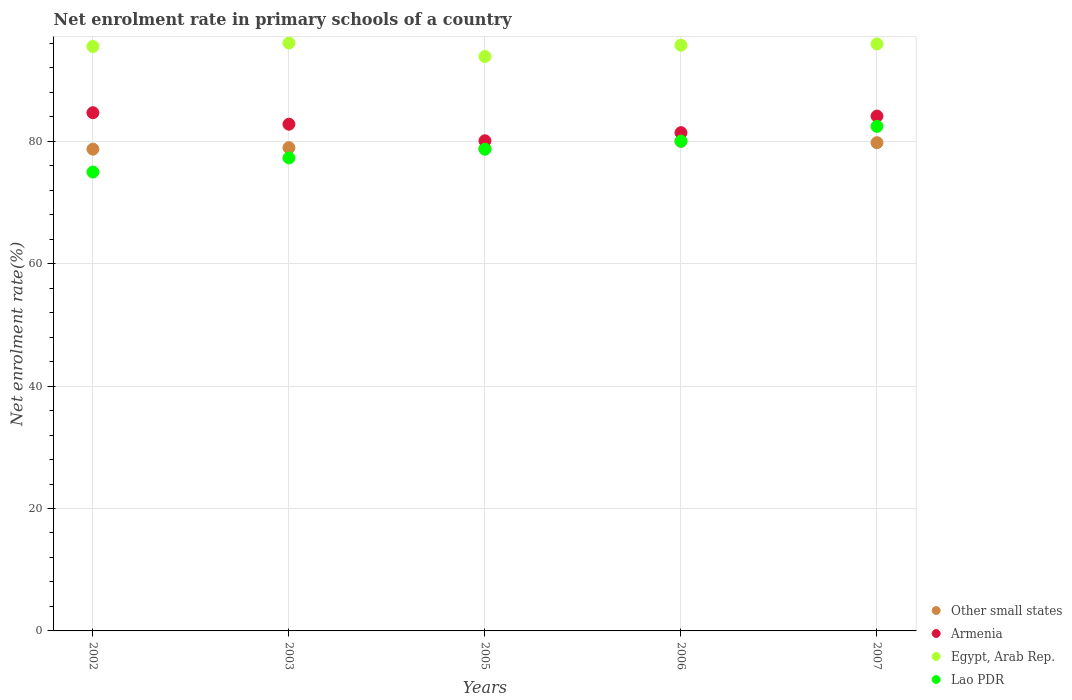Is the number of dotlines equal to the number of legend labels?
Your response must be concise. Yes. What is the net enrolment rate in primary schools in Armenia in 2005?
Ensure brevity in your answer.  80.09. Across all years, what is the maximum net enrolment rate in primary schools in Egypt, Arab Rep.?
Ensure brevity in your answer.  96.06. Across all years, what is the minimum net enrolment rate in primary schools in Egypt, Arab Rep.?
Your answer should be very brief. 93.85. What is the total net enrolment rate in primary schools in Lao PDR in the graph?
Your response must be concise. 393.45. What is the difference between the net enrolment rate in primary schools in Lao PDR in 2002 and that in 2003?
Keep it short and to the point. -2.31. What is the difference between the net enrolment rate in primary schools in Armenia in 2003 and the net enrolment rate in primary schools in Other small states in 2005?
Your answer should be very brief. 3.98. What is the average net enrolment rate in primary schools in Lao PDR per year?
Ensure brevity in your answer.  78.69. In the year 2003, what is the difference between the net enrolment rate in primary schools in Lao PDR and net enrolment rate in primary schools in Armenia?
Offer a terse response. -5.51. What is the ratio of the net enrolment rate in primary schools in Lao PDR in 2002 to that in 2007?
Your answer should be compact. 0.91. Is the difference between the net enrolment rate in primary schools in Lao PDR in 2003 and 2007 greater than the difference between the net enrolment rate in primary schools in Armenia in 2003 and 2007?
Provide a succinct answer. No. What is the difference between the highest and the second highest net enrolment rate in primary schools in Armenia?
Ensure brevity in your answer.  0.55. What is the difference between the highest and the lowest net enrolment rate in primary schools in Armenia?
Offer a terse response. 4.58. In how many years, is the net enrolment rate in primary schools in Lao PDR greater than the average net enrolment rate in primary schools in Lao PDR taken over all years?
Your response must be concise. 3. Is it the case that in every year, the sum of the net enrolment rate in primary schools in Other small states and net enrolment rate in primary schools in Lao PDR  is greater than the sum of net enrolment rate in primary schools in Armenia and net enrolment rate in primary schools in Egypt, Arab Rep.?
Give a very brief answer. No. Is the net enrolment rate in primary schools in Other small states strictly greater than the net enrolment rate in primary schools in Egypt, Arab Rep. over the years?
Your answer should be very brief. No. Is the net enrolment rate in primary schools in Armenia strictly less than the net enrolment rate in primary schools in Lao PDR over the years?
Offer a terse response. No. What is the difference between two consecutive major ticks on the Y-axis?
Give a very brief answer. 20. Are the values on the major ticks of Y-axis written in scientific E-notation?
Your response must be concise. No. Does the graph contain grids?
Keep it short and to the point. Yes. Where does the legend appear in the graph?
Give a very brief answer. Bottom right. How many legend labels are there?
Ensure brevity in your answer.  4. How are the legend labels stacked?
Make the answer very short. Vertical. What is the title of the graph?
Offer a very short reply. Net enrolment rate in primary schools of a country. What is the label or title of the Y-axis?
Give a very brief answer. Net enrolment rate(%). What is the Net enrolment rate(%) of Other small states in 2002?
Give a very brief answer. 78.72. What is the Net enrolment rate(%) in Armenia in 2002?
Your response must be concise. 84.67. What is the Net enrolment rate(%) in Egypt, Arab Rep. in 2002?
Ensure brevity in your answer.  95.49. What is the Net enrolment rate(%) of Lao PDR in 2002?
Keep it short and to the point. 74.98. What is the Net enrolment rate(%) of Other small states in 2003?
Provide a succinct answer. 78.96. What is the Net enrolment rate(%) of Armenia in 2003?
Your answer should be very brief. 82.79. What is the Net enrolment rate(%) of Egypt, Arab Rep. in 2003?
Ensure brevity in your answer.  96.06. What is the Net enrolment rate(%) in Lao PDR in 2003?
Your response must be concise. 77.29. What is the Net enrolment rate(%) of Other small states in 2005?
Provide a short and direct response. 78.81. What is the Net enrolment rate(%) of Armenia in 2005?
Give a very brief answer. 80.09. What is the Net enrolment rate(%) in Egypt, Arab Rep. in 2005?
Make the answer very short. 93.85. What is the Net enrolment rate(%) in Lao PDR in 2005?
Keep it short and to the point. 78.71. What is the Net enrolment rate(%) in Other small states in 2006?
Your answer should be very brief. 79.99. What is the Net enrolment rate(%) in Armenia in 2006?
Your response must be concise. 81.41. What is the Net enrolment rate(%) of Egypt, Arab Rep. in 2006?
Your answer should be compact. 95.7. What is the Net enrolment rate(%) in Lao PDR in 2006?
Your answer should be compact. 80.04. What is the Net enrolment rate(%) of Other small states in 2007?
Your response must be concise. 79.77. What is the Net enrolment rate(%) of Armenia in 2007?
Ensure brevity in your answer.  84.12. What is the Net enrolment rate(%) of Egypt, Arab Rep. in 2007?
Offer a very short reply. 95.9. What is the Net enrolment rate(%) of Lao PDR in 2007?
Ensure brevity in your answer.  82.44. Across all years, what is the maximum Net enrolment rate(%) of Other small states?
Your answer should be compact. 79.99. Across all years, what is the maximum Net enrolment rate(%) in Armenia?
Ensure brevity in your answer.  84.67. Across all years, what is the maximum Net enrolment rate(%) in Egypt, Arab Rep.?
Offer a very short reply. 96.06. Across all years, what is the maximum Net enrolment rate(%) in Lao PDR?
Your answer should be compact. 82.44. Across all years, what is the minimum Net enrolment rate(%) in Other small states?
Your response must be concise. 78.72. Across all years, what is the minimum Net enrolment rate(%) of Armenia?
Provide a short and direct response. 80.09. Across all years, what is the minimum Net enrolment rate(%) of Egypt, Arab Rep.?
Offer a terse response. 93.85. Across all years, what is the minimum Net enrolment rate(%) of Lao PDR?
Provide a succinct answer. 74.98. What is the total Net enrolment rate(%) of Other small states in the graph?
Offer a terse response. 396.26. What is the total Net enrolment rate(%) of Armenia in the graph?
Your answer should be very brief. 413.08. What is the total Net enrolment rate(%) of Egypt, Arab Rep. in the graph?
Make the answer very short. 477. What is the total Net enrolment rate(%) in Lao PDR in the graph?
Provide a succinct answer. 393.45. What is the difference between the Net enrolment rate(%) in Other small states in 2002 and that in 2003?
Ensure brevity in your answer.  -0.24. What is the difference between the Net enrolment rate(%) in Armenia in 2002 and that in 2003?
Offer a terse response. 1.88. What is the difference between the Net enrolment rate(%) in Egypt, Arab Rep. in 2002 and that in 2003?
Make the answer very short. -0.56. What is the difference between the Net enrolment rate(%) of Lao PDR in 2002 and that in 2003?
Your answer should be very brief. -2.31. What is the difference between the Net enrolment rate(%) in Other small states in 2002 and that in 2005?
Provide a succinct answer. -0.1. What is the difference between the Net enrolment rate(%) in Armenia in 2002 and that in 2005?
Provide a succinct answer. 4.58. What is the difference between the Net enrolment rate(%) in Egypt, Arab Rep. in 2002 and that in 2005?
Ensure brevity in your answer.  1.64. What is the difference between the Net enrolment rate(%) of Lao PDR in 2002 and that in 2005?
Keep it short and to the point. -3.73. What is the difference between the Net enrolment rate(%) in Other small states in 2002 and that in 2006?
Offer a terse response. -1.27. What is the difference between the Net enrolment rate(%) of Armenia in 2002 and that in 2006?
Give a very brief answer. 3.26. What is the difference between the Net enrolment rate(%) in Egypt, Arab Rep. in 2002 and that in 2006?
Your answer should be very brief. -0.2. What is the difference between the Net enrolment rate(%) in Lao PDR in 2002 and that in 2006?
Give a very brief answer. -5.06. What is the difference between the Net enrolment rate(%) of Other small states in 2002 and that in 2007?
Give a very brief answer. -1.05. What is the difference between the Net enrolment rate(%) of Armenia in 2002 and that in 2007?
Make the answer very short. 0.55. What is the difference between the Net enrolment rate(%) in Egypt, Arab Rep. in 2002 and that in 2007?
Keep it short and to the point. -0.41. What is the difference between the Net enrolment rate(%) in Lao PDR in 2002 and that in 2007?
Make the answer very short. -7.47. What is the difference between the Net enrolment rate(%) of Other small states in 2003 and that in 2005?
Offer a terse response. 0.14. What is the difference between the Net enrolment rate(%) of Armenia in 2003 and that in 2005?
Provide a succinct answer. 2.7. What is the difference between the Net enrolment rate(%) in Egypt, Arab Rep. in 2003 and that in 2005?
Give a very brief answer. 2.21. What is the difference between the Net enrolment rate(%) of Lao PDR in 2003 and that in 2005?
Offer a terse response. -1.42. What is the difference between the Net enrolment rate(%) in Other small states in 2003 and that in 2006?
Keep it short and to the point. -1.03. What is the difference between the Net enrolment rate(%) in Armenia in 2003 and that in 2006?
Provide a succinct answer. 1.38. What is the difference between the Net enrolment rate(%) in Egypt, Arab Rep. in 2003 and that in 2006?
Your answer should be very brief. 0.36. What is the difference between the Net enrolment rate(%) in Lao PDR in 2003 and that in 2006?
Provide a short and direct response. -2.75. What is the difference between the Net enrolment rate(%) of Other small states in 2003 and that in 2007?
Give a very brief answer. -0.81. What is the difference between the Net enrolment rate(%) of Armenia in 2003 and that in 2007?
Your answer should be very brief. -1.33. What is the difference between the Net enrolment rate(%) of Egypt, Arab Rep. in 2003 and that in 2007?
Your answer should be compact. 0.15. What is the difference between the Net enrolment rate(%) in Lao PDR in 2003 and that in 2007?
Provide a succinct answer. -5.16. What is the difference between the Net enrolment rate(%) in Other small states in 2005 and that in 2006?
Your answer should be compact. -1.18. What is the difference between the Net enrolment rate(%) of Armenia in 2005 and that in 2006?
Provide a short and direct response. -1.33. What is the difference between the Net enrolment rate(%) in Egypt, Arab Rep. in 2005 and that in 2006?
Offer a very short reply. -1.84. What is the difference between the Net enrolment rate(%) in Lao PDR in 2005 and that in 2006?
Offer a very short reply. -1.33. What is the difference between the Net enrolment rate(%) of Other small states in 2005 and that in 2007?
Make the answer very short. -0.96. What is the difference between the Net enrolment rate(%) of Armenia in 2005 and that in 2007?
Your answer should be compact. -4.03. What is the difference between the Net enrolment rate(%) of Egypt, Arab Rep. in 2005 and that in 2007?
Give a very brief answer. -2.05. What is the difference between the Net enrolment rate(%) in Lao PDR in 2005 and that in 2007?
Offer a very short reply. -3.73. What is the difference between the Net enrolment rate(%) of Other small states in 2006 and that in 2007?
Provide a succinct answer. 0.22. What is the difference between the Net enrolment rate(%) in Armenia in 2006 and that in 2007?
Offer a very short reply. -2.71. What is the difference between the Net enrolment rate(%) of Egypt, Arab Rep. in 2006 and that in 2007?
Your answer should be very brief. -0.21. What is the difference between the Net enrolment rate(%) of Lao PDR in 2006 and that in 2007?
Give a very brief answer. -2.4. What is the difference between the Net enrolment rate(%) in Other small states in 2002 and the Net enrolment rate(%) in Armenia in 2003?
Give a very brief answer. -4.07. What is the difference between the Net enrolment rate(%) in Other small states in 2002 and the Net enrolment rate(%) in Egypt, Arab Rep. in 2003?
Offer a terse response. -17.34. What is the difference between the Net enrolment rate(%) in Other small states in 2002 and the Net enrolment rate(%) in Lao PDR in 2003?
Your answer should be very brief. 1.43. What is the difference between the Net enrolment rate(%) of Armenia in 2002 and the Net enrolment rate(%) of Egypt, Arab Rep. in 2003?
Offer a very short reply. -11.39. What is the difference between the Net enrolment rate(%) of Armenia in 2002 and the Net enrolment rate(%) of Lao PDR in 2003?
Keep it short and to the point. 7.39. What is the difference between the Net enrolment rate(%) of Egypt, Arab Rep. in 2002 and the Net enrolment rate(%) of Lao PDR in 2003?
Provide a short and direct response. 18.21. What is the difference between the Net enrolment rate(%) of Other small states in 2002 and the Net enrolment rate(%) of Armenia in 2005?
Offer a very short reply. -1.37. What is the difference between the Net enrolment rate(%) of Other small states in 2002 and the Net enrolment rate(%) of Egypt, Arab Rep. in 2005?
Your answer should be compact. -15.13. What is the difference between the Net enrolment rate(%) of Other small states in 2002 and the Net enrolment rate(%) of Lao PDR in 2005?
Offer a very short reply. 0.01. What is the difference between the Net enrolment rate(%) of Armenia in 2002 and the Net enrolment rate(%) of Egypt, Arab Rep. in 2005?
Your response must be concise. -9.18. What is the difference between the Net enrolment rate(%) of Armenia in 2002 and the Net enrolment rate(%) of Lao PDR in 2005?
Provide a short and direct response. 5.96. What is the difference between the Net enrolment rate(%) in Egypt, Arab Rep. in 2002 and the Net enrolment rate(%) in Lao PDR in 2005?
Your answer should be very brief. 16.79. What is the difference between the Net enrolment rate(%) of Other small states in 2002 and the Net enrolment rate(%) of Armenia in 2006?
Provide a short and direct response. -2.69. What is the difference between the Net enrolment rate(%) of Other small states in 2002 and the Net enrolment rate(%) of Egypt, Arab Rep. in 2006?
Your response must be concise. -16.98. What is the difference between the Net enrolment rate(%) of Other small states in 2002 and the Net enrolment rate(%) of Lao PDR in 2006?
Offer a very short reply. -1.32. What is the difference between the Net enrolment rate(%) of Armenia in 2002 and the Net enrolment rate(%) of Egypt, Arab Rep. in 2006?
Your answer should be very brief. -11.02. What is the difference between the Net enrolment rate(%) of Armenia in 2002 and the Net enrolment rate(%) of Lao PDR in 2006?
Your answer should be very brief. 4.63. What is the difference between the Net enrolment rate(%) of Egypt, Arab Rep. in 2002 and the Net enrolment rate(%) of Lao PDR in 2006?
Ensure brevity in your answer.  15.46. What is the difference between the Net enrolment rate(%) in Other small states in 2002 and the Net enrolment rate(%) in Armenia in 2007?
Offer a very short reply. -5.4. What is the difference between the Net enrolment rate(%) in Other small states in 2002 and the Net enrolment rate(%) in Egypt, Arab Rep. in 2007?
Offer a terse response. -17.18. What is the difference between the Net enrolment rate(%) of Other small states in 2002 and the Net enrolment rate(%) of Lao PDR in 2007?
Provide a short and direct response. -3.72. What is the difference between the Net enrolment rate(%) in Armenia in 2002 and the Net enrolment rate(%) in Egypt, Arab Rep. in 2007?
Provide a succinct answer. -11.23. What is the difference between the Net enrolment rate(%) in Armenia in 2002 and the Net enrolment rate(%) in Lao PDR in 2007?
Keep it short and to the point. 2.23. What is the difference between the Net enrolment rate(%) in Egypt, Arab Rep. in 2002 and the Net enrolment rate(%) in Lao PDR in 2007?
Keep it short and to the point. 13.05. What is the difference between the Net enrolment rate(%) of Other small states in 2003 and the Net enrolment rate(%) of Armenia in 2005?
Offer a very short reply. -1.13. What is the difference between the Net enrolment rate(%) in Other small states in 2003 and the Net enrolment rate(%) in Egypt, Arab Rep. in 2005?
Your answer should be very brief. -14.89. What is the difference between the Net enrolment rate(%) of Other small states in 2003 and the Net enrolment rate(%) of Lao PDR in 2005?
Make the answer very short. 0.25. What is the difference between the Net enrolment rate(%) of Armenia in 2003 and the Net enrolment rate(%) of Egypt, Arab Rep. in 2005?
Make the answer very short. -11.06. What is the difference between the Net enrolment rate(%) of Armenia in 2003 and the Net enrolment rate(%) of Lao PDR in 2005?
Give a very brief answer. 4.08. What is the difference between the Net enrolment rate(%) of Egypt, Arab Rep. in 2003 and the Net enrolment rate(%) of Lao PDR in 2005?
Keep it short and to the point. 17.35. What is the difference between the Net enrolment rate(%) in Other small states in 2003 and the Net enrolment rate(%) in Armenia in 2006?
Offer a very short reply. -2.45. What is the difference between the Net enrolment rate(%) of Other small states in 2003 and the Net enrolment rate(%) of Egypt, Arab Rep. in 2006?
Provide a succinct answer. -16.74. What is the difference between the Net enrolment rate(%) in Other small states in 2003 and the Net enrolment rate(%) in Lao PDR in 2006?
Give a very brief answer. -1.08. What is the difference between the Net enrolment rate(%) of Armenia in 2003 and the Net enrolment rate(%) of Egypt, Arab Rep. in 2006?
Make the answer very short. -12.9. What is the difference between the Net enrolment rate(%) of Armenia in 2003 and the Net enrolment rate(%) of Lao PDR in 2006?
Ensure brevity in your answer.  2.75. What is the difference between the Net enrolment rate(%) of Egypt, Arab Rep. in 2003 and the Net enrolment rate(%) of Lao PDR in 2006?
Your answer should be very brief. 16.02. What is the difference between the Net enrolment rate(%) in Other small states in 2003 and the Net enrolment rate(%) in Armenia in 2007?
Provide a short and direct response. -5.16. What is the difference between the Net enrolment rate(%) in Other small states in 2003 and the Net enrolment rate(%) in Egypt, Arab Rep. in 2007?
Provide a succinct answer. -16.94. What is the difference between the Net enrolment rate(%) in Other small states in 2003 and the Net enrolment rate(%) in Lao PDR in 2007?
Ensure brevity in your answer.  -3.48. What is the difference between the Net enrolment rate(%) in Armenia in 2003 and the Net enrolment rate(%) in Egypt, Arab Rep. in 2007?
Offer a terse response. -13.11. What is the difference between the Net enrolment rate(%) of Egypt, Arab Rep. in 2003 and the Net enrolment rate(%) of Lao PDR in 2007?
Your response must be concise. 13.61. What is the difference between the Net enrolment rate(%) of Other small states in 2005 and the Net enrolment rate(%) of Armenia in 2006?
Your answer should be very brief. -2.6. What is the difference between the Net enrolment rate(%) of Other small states in 2005 and the Net enrolment rate(%) of Egypt, Arab Rep. in 2006?
Offer a terse response. -16.88. What is the difference between the Net enrolment rate(%) in Other small states in 2005 and the Net enrolment rate(%) in Lao PDR in 2006?
Offer a very short reply. -1.22. What is the difference between the Net enrolment rate(%) in Armenia in 2005 and the Net enrolment rate(%) in Egypt, Arab Rep. in 2006?
Ensure brevity in your answer.  -15.61. What is the difference between the Net enrolment rate(%) in Armenia in 2005 and the Net enrolment rate(%) in Lao PDR in 2006?
Make the answer very short. 0.05. What is the difference between the Net enrolment rate(%) of Egypt, Arab Rep. in 2005 and the Net enrolment rate(%) of Lao PDR in 2006?
Keep it short and to the point. 13.81. What is the difference between the Net enrolment rate(%) of Other small states in 2005 and the Net enrolment rate(%) of Armenia in 2007?
Make the answer very short. -5.3. What is the difference between the Net enrolment rate(%) in Other small states in 2005 and the Net enrolment rate(%) in Egypt, Arab Rep. in 2007?
Your response must be concise. -17.09. What is the difference between the Net enrolment rate(%) of Other small states in 2005 and the Net enrolment rate(%) of Lao PDR in 2007?
Keep it short and to the point. -3.63. What is the difference between the Net enrolment rate(%) in Armenia in 2005 and the Net enrolment rate(%) in Egypt, Arab Rep. in 2007?
Your answer should be compact. -15.81. What is the difference between the Net enrolment rate(%) of Armenia in 2005 and the Net enrolment rate(%) of Lao PDR in 2007?
Provide a short and direct response. -2.35. What is the difference between the Net enrolment rate(%) in Egypt, Arab Rep. in 2005 and the Net enrolment rate(%) in Lao PDR in 2007?
Offer a terse response. 11.41. What is the difference between the Net enrolment rate(%) of Other small states in 2006 and the Net enrolment rate(%) of Armenia in 2007?
Offer a very short reply. -4.13. What is the difference between the Net enrolment rate(%) of Other small states in 2006 and the Net enrolment rate(%) of Egypt, Arab Rep. in 2007?
Give a very brief answer. -15.91. What is the difference between the Net enrolment rate(%) in Other small states in 2006 and the Net enrolment rate(%) in Lao PDR in 2007?
Offer a terse response. -2.45. What is the difference between the Net enrolment rate(%) of Armenia in 2006 and the Net enrolment rate(%) of Egypt, Arab Rep. in 2007?
Provide a succinct answer. -14.49. What is the difference between the Net enrolment rate(%) of Armenia in 2006 and the Net enrolment rate(%) of Lao PDR in 2007?
Your response must be concise. -1.03. What is the difference between the Net enrolment rate(%) in Egypt, Arab Rep. in 2006 and the Net enrolment rate(%) in Lao PDR in 2007?
Ensure brevity in your answer.  13.25. What is the average Net enrolment rate(%) in Other small states per year?
Your answer should be compact. 79.25. What is the average Net enrolment rate(%) of Armenia per year?
Give a very brief answer. 82.62. What is the average Net enrolment rate(%) of Egypt, Arab Rep. per year?
Provide a short and direct response. 95.4. What is the average Net enrolment rate(%) of Lao PDR per year?
Your answer should be very brief. 78.69. In the year 2002, what is the difference between the Net enrolment rate(%) of Other small states and Net enrolment rate(%) of Armenia?
Provide a succinct answer. -5.95. In the year 2002, what is the difference between the Net enrolment rate(%) of Other small states and Net enrolment rate(%) of Egypt, Arab Rep.?
Make the answer very short. -16.78. In the year 2002, what is the difference between the Net enrolment rate(%) of Other small states and Net enrolment rate(%) of Lao PDR?
Keep it short and to the point. 3.74. In the year 2002, what is the difference between the Net enrolment rate(%) of Armenia and Net enrolment rate(%) of Egypt, Arab Rep.?
Ensure brevity in your answer.  -10.82. In the year 2002, what is the difference between the Net enrolment rate(%) in Armenia and Net enrolment rate(%) in Lao PDR?
Your answer should be compact. 9.69. In the year 2002, what is the difference between the Net enrolment rate(%) of Egypt, Arab Rep. and Net enrolment rate(%) of Lao PDR?
Your answer should be very brief. 20.52. In the year 2003, what is the difference between the Net enrolment rate(%) of Other small states and Net enrolment rate(%) of Armenia?
Provide a succinct answer. -3.83. In the year 2003, what is the difference between the Net enrolment rate(%) in Other small states and Net enrolment rate(%) in Egypt, Arab Rep.?
Give a very brief answer. -17.1. In the year 2003, what is the difference between the Net enrolment rate(%) in Other small states and Net enrolment rate(%) in Lao PDR?
Offer a very short reply. 1.67. In the year 2003, what is the difference between the Net enrolment rate(%) in Armenia and Net enrolment rate(%) in Egypt, Arab Rep.?
Keep it short and to the point. -13.27. In the year 2003, what is the difference between the Net enrolment rate(%) in Armenia and Net enrolment rate(%) in Lao PDR?
Ensure brevity in your answer.  5.51. In the year 2003, what is the difference between the Net enrolment rate(%) of Egypt, Arab Rep. and Net enrolment rate(%) of Lao PDR?
Your response must be concise. 18.77. In the year 2005, what is the difference between the Net enrolment rate(%) of Other small states and Net enrolment rate(%) of Armenia?
Ensure brevity in your answer.  -1.27. In the year 2005, what is the difference between the Net enrolment rate(%) in Other small states and Net enrolment rate(%) in Egypt, Arab Rep.?
Give a very brief answer. -15.04. In the year 2005, what is the difference between the Net enrolment rate(%) of Other small states and Net enrolment rate(%) of Lao PDR?
Ensure brevity in your answer.  0.11. In the year 2005, what is the difference between the Net enrolment rate(%) in Armenia and Net enrolment rate(%) in Egypt, Arab Rep.?
Your answer should be very brief. -13.76. In the year 2005, what is the difference between the Net enrolment rate(%) of Armenia and Net enrolment rate(%) of Lao PDR?
Give a very brief answer. 1.38. In the year 2005, what is the difference between the Net enrolment rate(%) in Egypt, Arab Rep. and Net enrolment rate(%) in Lao PDR?
Give a very brief answer. 15.14. In the year 2006, what is the difference between the Net enrolment rate(%) in Other small states and Net enrolment rate(%) in Armenia?
Your response must be concise. -1.42. In the year 2006, what is the difference between the Net enrolment rate(%) in Other small states and Net enrolment rate(%) in Egypt, Arab Rep.?
Your answer should be very brief. -15.7. In the year 2006, what is the difference between the Net enrolment rate(%) in Other small states and Net enrolment rate(%) in Lao PDR?
Provide a succinct answer. -0.04. In the year 2006, what is the difference between the Net enrolment rate(%) of Armenia and Net enrolment rate(%) of Egypt, Arab Rep.?
Your response must be concise. -14.28. In the year 2006, what is the difference between the Net enrolment rate(%) of Armenia and Net enrolment rate(%) of Lao PDR?
Give a very brief answer. 1.38. In the year 2006, what is the difference between the Net enrolment rate(%) of Egypt, Arab Rep. and Net enrolment rate(%) of Lao PDR?
Make the answer very short. 15.66. In the year 2007, what is the difference between the Net enrolment rate(%) in Other small states and Net enrolment rate(%) in Armenia?
Make the answer very short. -4.35. In the year 2007, what is the difference between the Net enrolment rate(%) in Other small states and Net enrolment rate(%) in Egypt, Arab Rep.?
Provide a short and direct response. -16.13. In the year 2007, what is the difference between the Net enrolment rate(%) in Other small states and Net enrolment rate(%) in Lao PDR?
Give a very brief answer. -2.67. In the year 2007, what is the difference between the Net enrolment rate(%) of Armenia and Net enrolment rate(%) of Egypt, Arab Rep.?
Provide a short and direct response. -11.78. In the year 2007, what is the difference between the Net enrolment rate(%) in Armenia and Net enrolment rate(%) in Lao PDR?
Make the answer very short. 1.68. In the year 2007, what is the difference between the Net enrolment rate(%) of Egypt, Arab Rep. and Net enrolment rate(%) of Lao PDR?
Provide a short and direct response. 13.46. What is the ratio of the Net enrolment rate(%) of Other small states in 2002 to that in 2003?
Provide a short and direct response. 1. What is the ratio of the Net enrolment rate(%) in Armenia in 2002 to that in 2003?
Provide a short and direct response. 1.02. What is the ratio of the Net enrolment rate(%) in Lao PDR in 2002 to that in 2003?
Provide a short and direct response. 0.97. What is the ratio of the Net enrolment rate(%) of Armenia in 2002 to that in 2005?
Provide a succinct answer. 1.06. What is the ratio of the Net enrolment rate(%) in Egypt, Arab Rep. in 2002 to that in 2005?
Offer a very short reply. 1.02. What is the ratio of the Net enrolment rate(%) in Lao PDR in 2002 to that in 2005?
Make the answer very short. 0.95. What is the ratio of the Net enrolment rate(%) in Other small states in 2002 to that in 2006?
Make the answer very short. 0.98. What is the ratio of the Net enrolment rate(%) in Egypt, Arab Rep. in 2002 to that in 2006?
Provide a short and direct response. 1. What is the ratio of the Net enrolment rate(%) in Lao PDR in 2002 to that in 2006?
Your answer should be compact. 0.94. What is the ratio of the Net enrolment rate(%) of Armenia in 2002 to that in 2007?
Ensure brevity in your answer.  1.01. What is the ratio of the Net enrolment rate(%) in Lao PDR in 2002 to that in 2007?
Keep it short and to the point. 0.91. What is the ratio of the Net enrolment rate(%) in Armenia in 2003 to that in 2005?
Your response must be concise. 1.03. What is the ratio of the Net enrolment rate(%) of Egypt, Arab Rep. in 2003 to that in 2005?
Ensure brevity in your answer.  1.02. What is the ratio of the Net enrolment rate(%) in Lao PDR in 2003 to that in 2005?
Your answer should be compact. 0.98. What is the ratio of the Net enrolment rate(%) of Other small states in 2003 to that in 2006?
Offer a terse response. 0.99. What is the ratio of the Net enrolment rate(%) in Armenia in 2003 to that in 2006?
Ensure brevity in your answer.  1.02. What is the ratio of the Net enrolment rate(%) of Lao PDR in 2003 to that in 2006?
Make the answer very short. 0.97. What is the ratio of the Net enrolment rate(%) in Other small states in 2003 to that in 2007?
Ensure brevity in your answer.  0.99. What is the ratio of the Net enrolment rate(%) in Armenia in 2003 to that in 2007?
Your answer should be very brief. 0.98. What is the ratio of the Net enrolment rate(%) in Egypt, Arab Rep. in 2003 to that in 2007?
Provide a succinct answer. 1. What is the ratio of the Net enrolment rate(%) in Lao PDR in 2003 to that in 2007?
Your response must be concise. 0.94. What is the ratio of the Net enrolment rate(%) of Armenia in 2005 to that in 2006?
Keep it short and to the point. 0.98. What is the ratio of the Net enrolment rate(%) in Egypt, Arab Rep. in 2005 to that in 2006?
Your answer should be very brief. 0.98. What is the ratio of the Net enrolment rate(%) of Lao PDR in 2005 to that in 2006?
Ensure brevity in your answer.  0.98. What is the ratio of the Net enrolment rate(%) of Other small states in 2005 to that in 2007?
Provide a succinct answer. 0.99. What is the ratio of the Net enrolment rate(%) of Armenia in 2005 to that in 2007?
Ensure brevity in your answer.  0.95. What is the ratio of the Net enrolment rate(%) in Egypt, Arab Rep. in 2005 to that in 2007?
Make the answer very short. 0.98. What is the ratio of the Net enrolment rate(%) in Lao PDR in 2005 to that in 2007?
Offer a terse response. 0.95. What is the ratio of the Net enrolment rate(%) of Armenia in 2006 to that in 2007?
Your answer should be compact. 0.97. What is the ratio of the Net enrolment rate(%) in Egypt, Arab Rep. in 2006 to that in 2007?
Offer a terse response. 1. What is the ratio of the Net enrolment rate(%) in Lao PDR in 2006 to that in 2007?
Your answer should be very brief. 0.97. What is the difference between the highest and the second highest Net enrolment rate(%) in Other small states?
Your answer should be compact. 0.22. What is the difference between the highest and the second highest Net enrolment rate(%) in Armenia?
Offer a very short reply. 0.55. What is the difference between the highest and the second highest Net enrolment rate(%) in Egypt, Arab Rep.?
Offer a very short reply. 0.15. What is the difference between the highest and the second highest Net enrolment rate(%) of Lao PDR?
Offer a terse response. 2.4. What is the difference between the highest and the lowest Net enrolment rate(%) in Other small states?
Give a very brief answer. 1.27. What is the difference between the highest and the lowest Net enrolment rate(%) of Armenia?
Your answer should be compact. 4.58. What is the difference between the highest and the lowest Net enrolment rate(%) of Egypt, Arab Rep.?
Provide a succinct answer. 2.21. What is the difference between the highest and the lowest Net enrolment rate(%) in Lao PDR?
Your answer should be very brief. 7.47. 